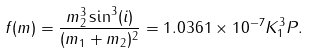Convert formula to latex. <formula><loc_0><loc_0><loc_500><loc_500>f ( m ) = \frac { m _ { 2 } ^ { 3 } \sin ^ { 3 } ( i ) } { ( m _ { 1 } + m _ { 2 } ) ^ { 2 } } = 1 . 0 3 6 1 \times 1 0 ^ { - 7 } K _ { 1 } ^ { 3 } P .</formula> 